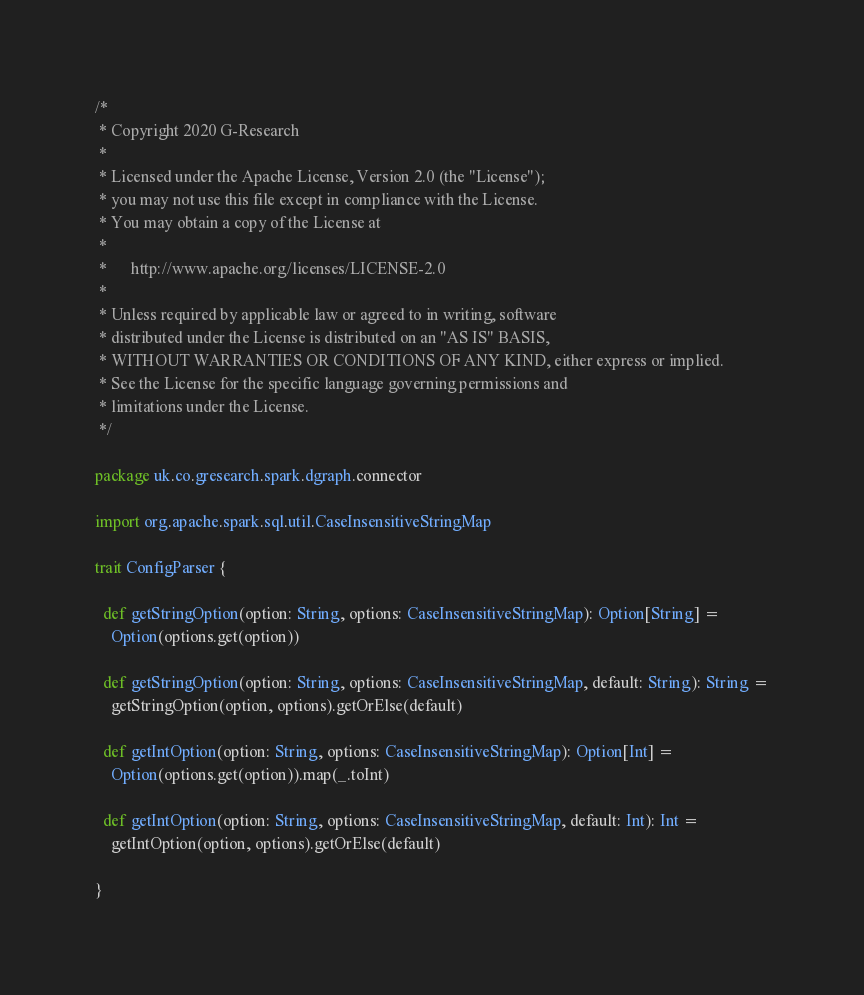<code> <loc_0><loc_0><loc_500><loc_500><_Scala_>/*
 * Copyright 2020 G-Research
 *
 * Licensed under the Apache License, Version 2.0 (the "License");
 * you may not use this file except in compliance with the License.
 * You may obtain a copy of the License at
 *
 *      http://www.apache.org/licenses/LICENSE-2.0
 *
 * Unless required by applicable law or agreed to in writing, software
 * distributed under the License is distributed on an "AS IS" BASIS,
 * WITHOUT WARRANTIES OR CONDITIONS OF ANY KIND, either express or implied.
 * See the License for the specific language governing permissions and
 * limitations under the License.
 */

package uk.co.gresearch.spark.dgraph.connector

import org.apache.spark.sql.util.CaseInsensitiveStringMap

trait ConfigParser {

  def getStringOption(option: String, options: CaseInsensitiveStringMap): Option[String] =
    Option(options.get(option))

  def getStringOption(option: String, options: CaseInsensitiveStringMap, default: String): String =
    getStringOption(option, options).getOrElse(default)

  def getIntOption(option: String, options: CaseInsensitiveStringMap): Option[Int] =
    Option(options.get(option)).map(_.toInt)

  def getIntOption(option: String, options: CaseInsensitiveStringMap, default: Int): Int =
    getIntOption(option, options).getOrElse(default)

}
</code> 